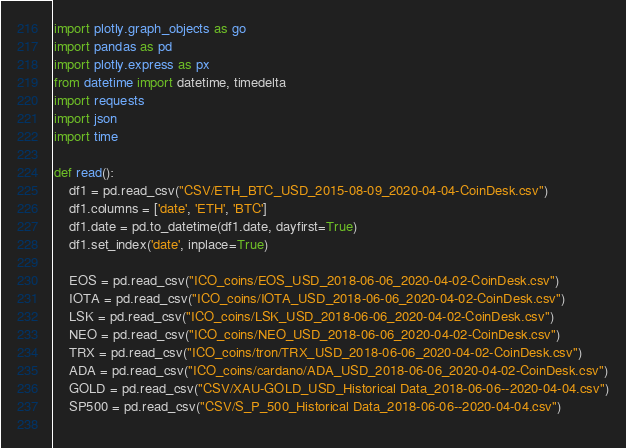<code> <loc_0><loc_0><loc_500><loc_500><_Python_>import plotly.graph_objects as go
import pandas as pd
import plotly.express as px
from datetime import datetime, timedelta
import requests
import json
import time

def read():
    df1 = pd.read_csv("CSV/ETH_BTC_USD_2015-08-09_2020-04-04-CoinDesk.csv")
    df1.columns = ['date', 'ETH', 'BTC']
    df1.date = pd.to_datetime(df1.date, dayfirst=True)
    df1.set_index('date', inplace=True)
    
    EOS = pd.read_csv("ICO_coins/EOS_USD_2018-06-06_2020-04-02-CoinDesk.csv")
    IOTA = pd.read_csv("ICO_coins/IOTA_USD_2018-06-06_2020-04-02-CoinDesk.csv") 
    LSK = pd.read_csv("ICO_coins/LSK_USD_2018-06-06_2020-04-02-CoinDesk.csv")
    NEO = pd.read_csv("ICO_coins/NEO_USD_2018-06-06_2020-04-02-CoinDesk.csv")
    TRX = pd.read_csv("ICO_coins/tron/TRX_USD_2018-06-06_2020-04-02-CoinDesk.csv")
    ADA = pd.read_csv("ICO_coins/cardano/ADA_USD_2018-06-06_2020-04-02-CoinDesk.csv")
    GOLD = pd.read_csv("CSV/XAU-GOLD_USD_Historical Data_2018-06-06--2020-04-04.csv")
    SP500 = pd.read_csv("CSV/S_P_500_Historical Data_2018-06-06--2020-04-04.csv")
    </code> 